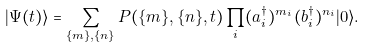<formula> <loc_0><loc_0><loc_500><loc_500>| \Psi ( t ) \rangle = \sum _ { \{ m \} , \{ n \} } P ( \{ m \} , \{ n \} , t ) \prod _ { i } ( { a } _ { i } ^ { \dag } ) ^ { m _ { i } } ( { b } _ { i } ^ { \dag } ) ^ { n _ { i } } | 0 \rangle .</formula> 